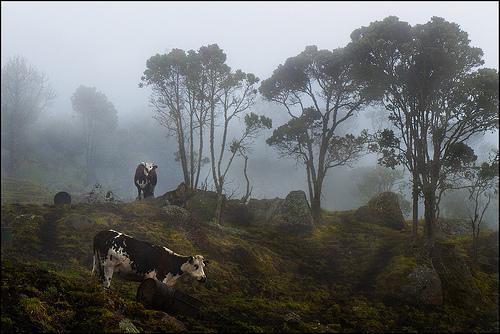How many cows do you see?
Give a very brief answer. 2. 